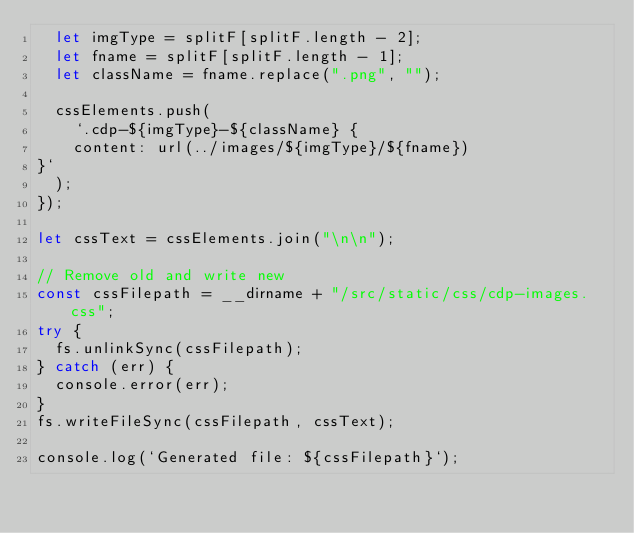<code> <loc_0><loc_0><loc_500><loc_500><_JavaScript_>  let imgType = splitF[splitF.length - 2];
  let fname = splitF[splitF.length - 1];
  let className = fname.replace(".png", "");

  cssElements.push(
    `.cdp-${imgType}-${className} {
    content: url(../images/${imgType}/${fname})
}`
  );
});

let cssText = cssElements.join("\n\n");

// Remove old and write new
const cssFilepath = __dirname + "/src/static/css/cdp-images.css";
try {
  fs.unlinkSync(cssFilepath);
} catch (err) {
  console.error(err);
}
fs.writeFileSync(cssFilepath, cssText);

console.log(`Generated file: ${cssFilepath}`);
</code> 